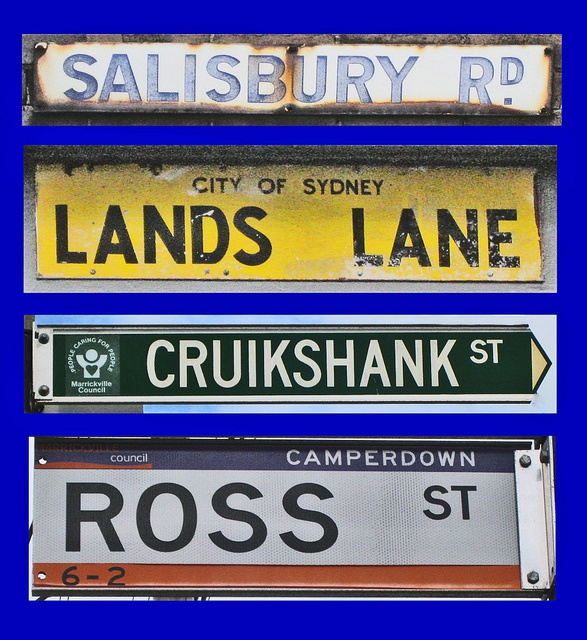Describe the objects in this image and their specific colors. I can see various objects in this image with different colors. 